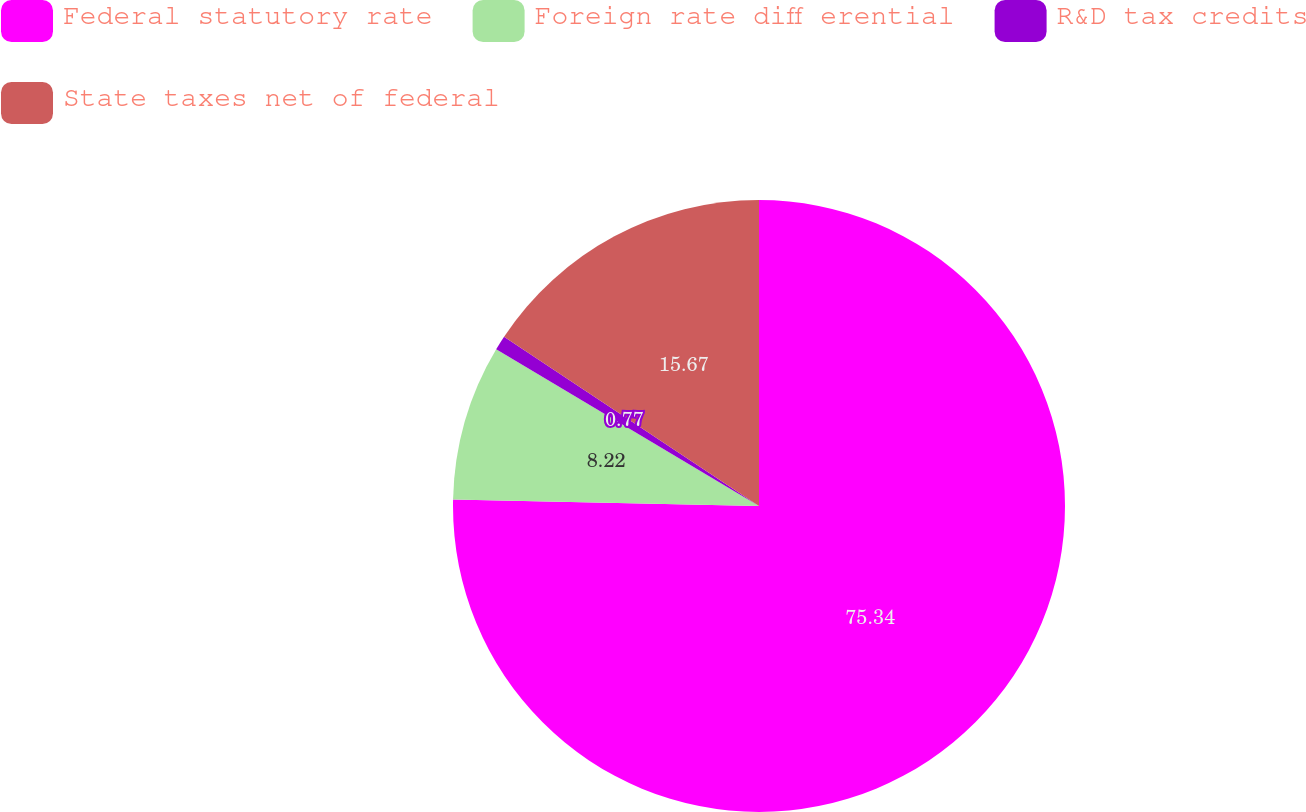Convert chart to OTSL. <chart><loc_0><loc_0><loc_500><loc_500><pie_chart><fcel>Federal statutory rate<fcel>Foreign rate diff erential<fcel>R&D tax credits<fcel>State taxes net of federal<nl><fcel>75.33%<fcel>8.22%<fcel>0.77%<fcel>15.67%<nl></chart> 